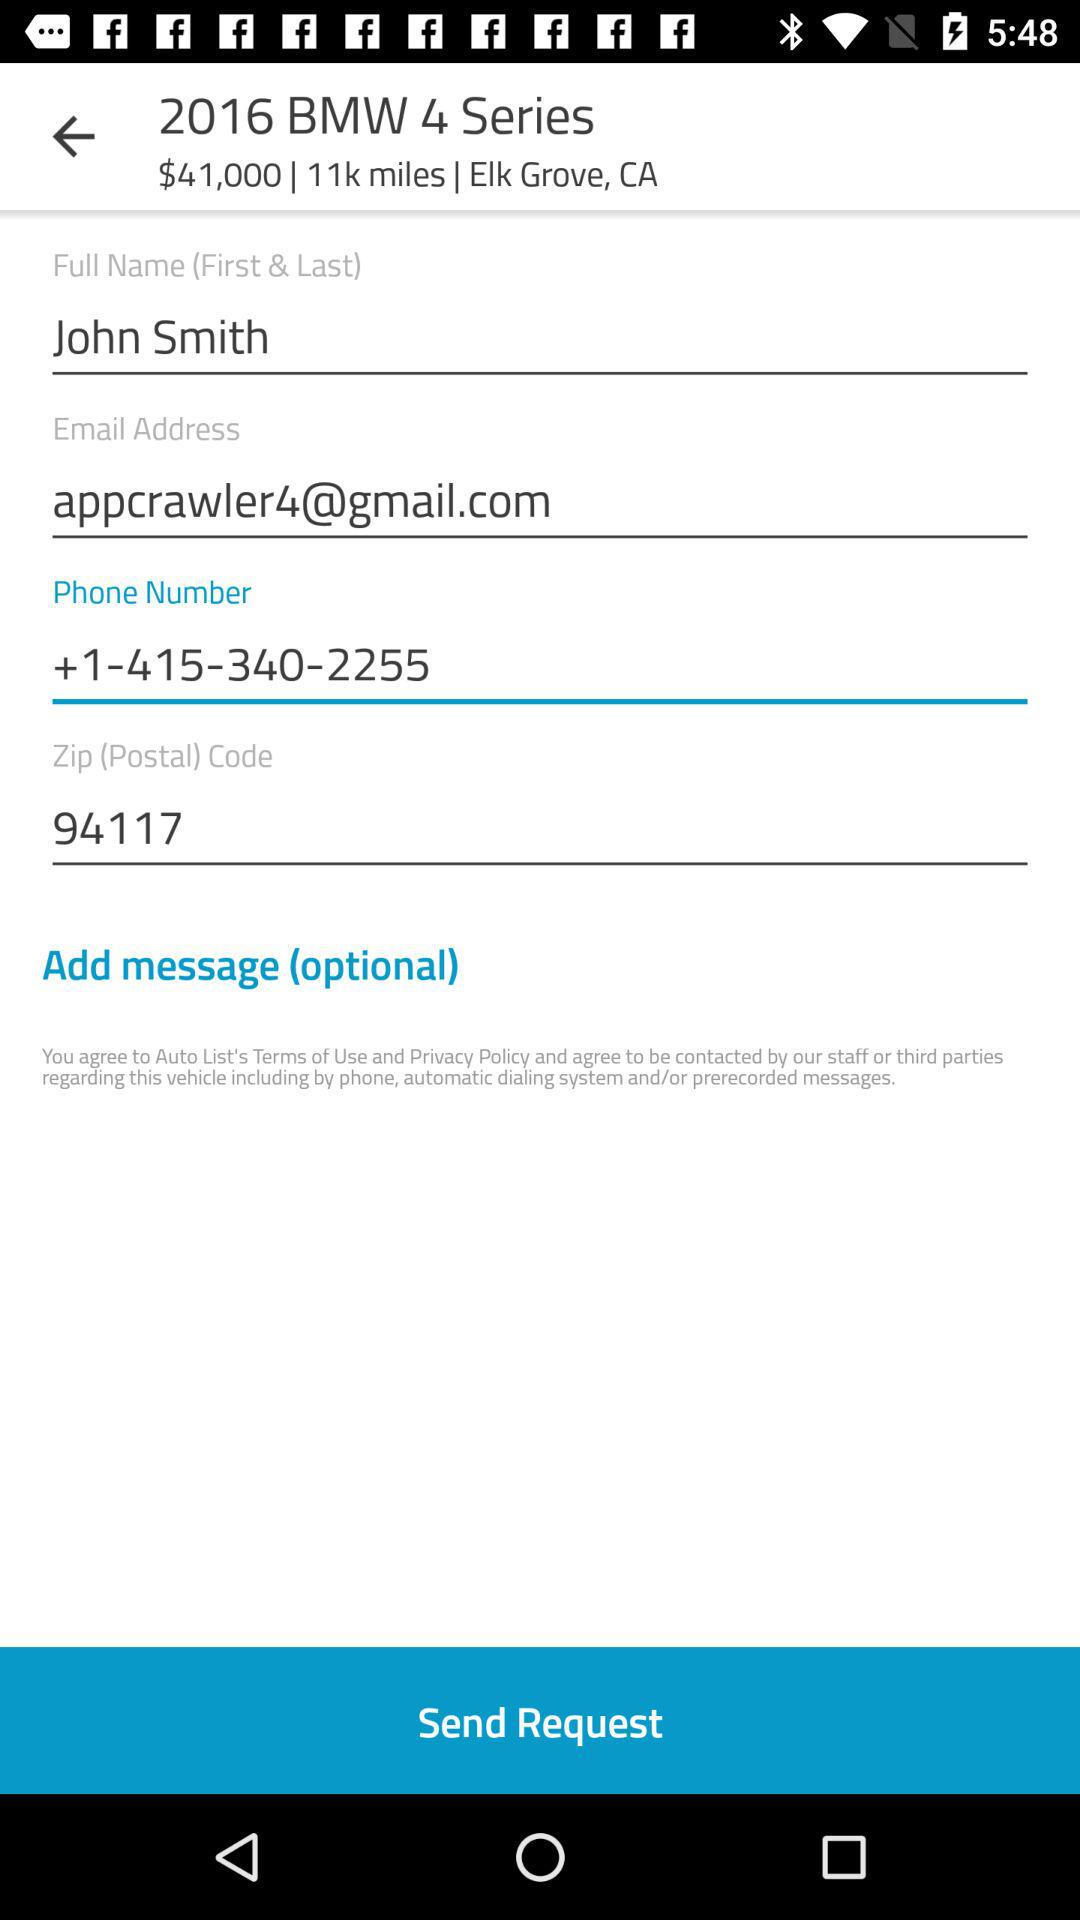What is the contact number of the user? The contact number is +1-415-340-2255. 